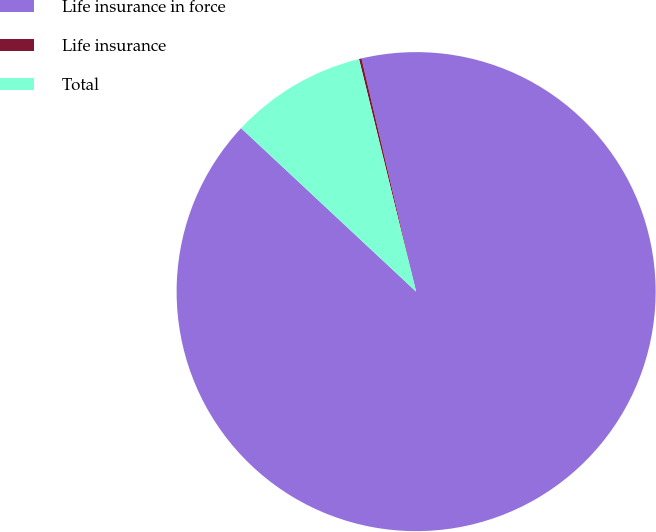Convert chart. <chart><loc_0><loc_0><loc_500><loc_500><pie_chart><fcel>Life insurance in force<fcel>Life insurance<fcel>Total<nl><fcel>90.62%<fcel>0.17%<fcel>9.21%<nl></chart> 